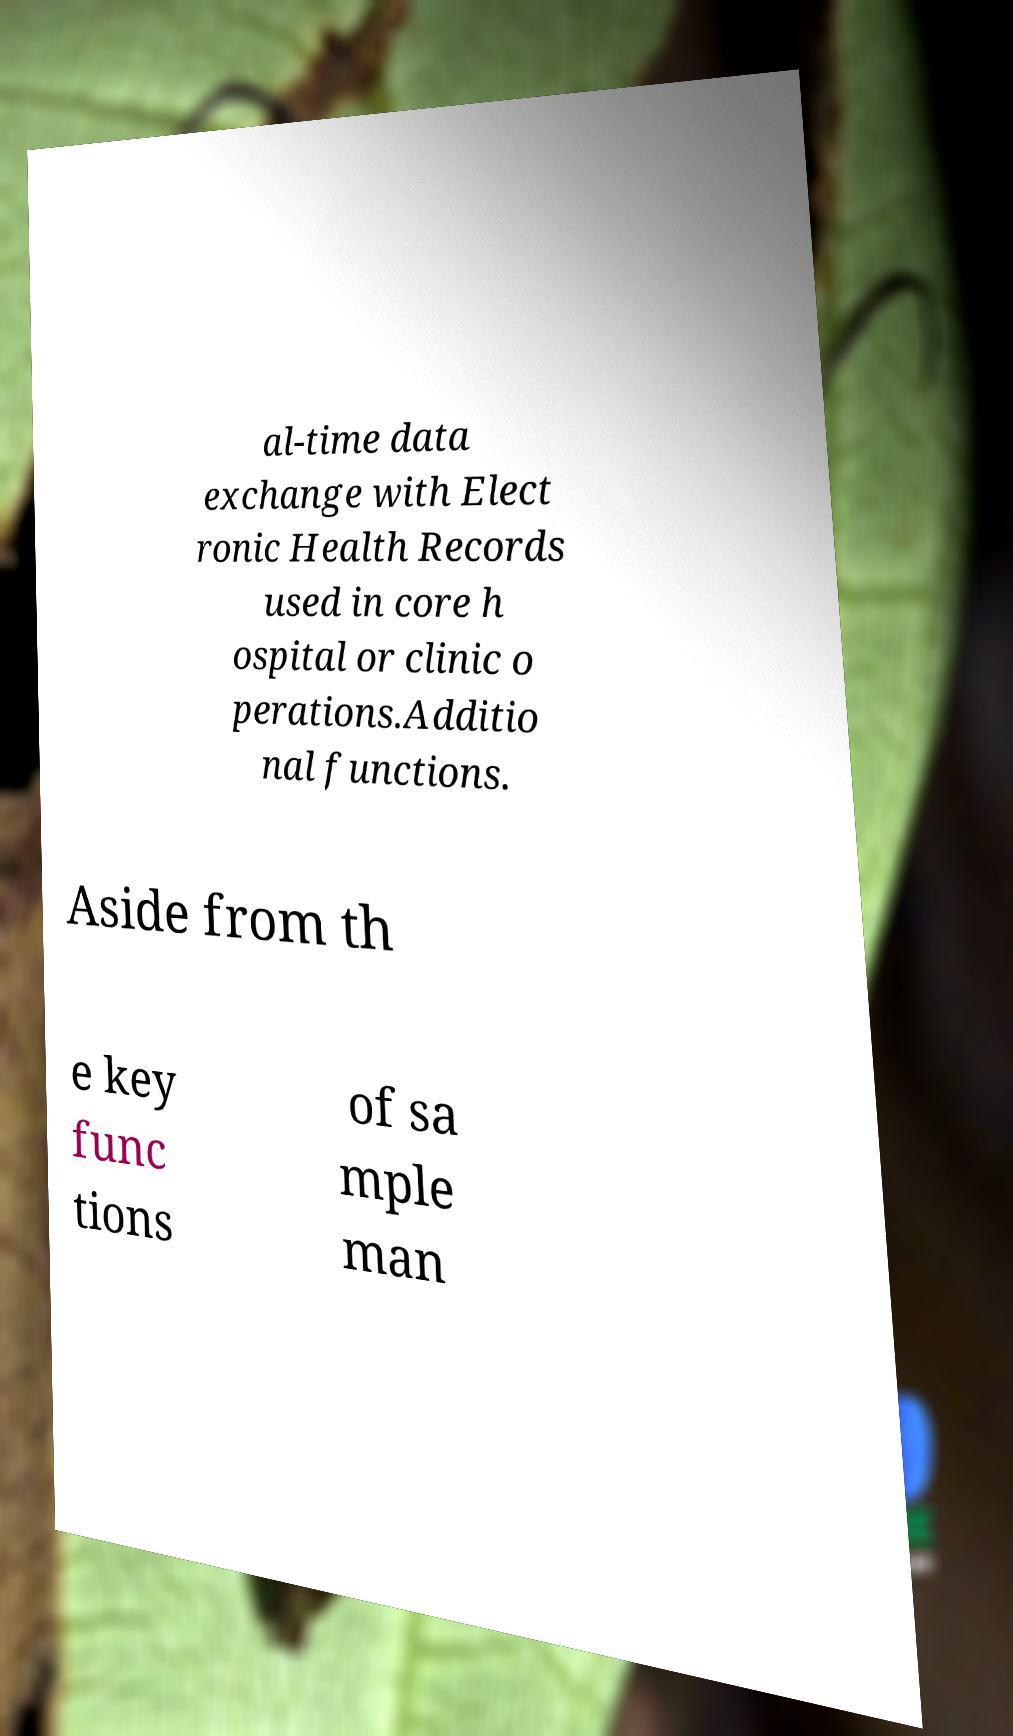Could you assist in decoding the text presented in this image and type it out clearly? al-time data exchange with Elect ronic Health Records used in core h ospital or clinic o perations.Additio nal functions. Aside from th e key func tions of sa mple man 